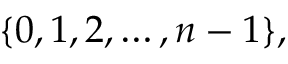<formula> <loc_0><loc_0><loc_500><loc_500>\{ 0 , 1 , 2 , \dots , n - 1 \} ,</formula> 